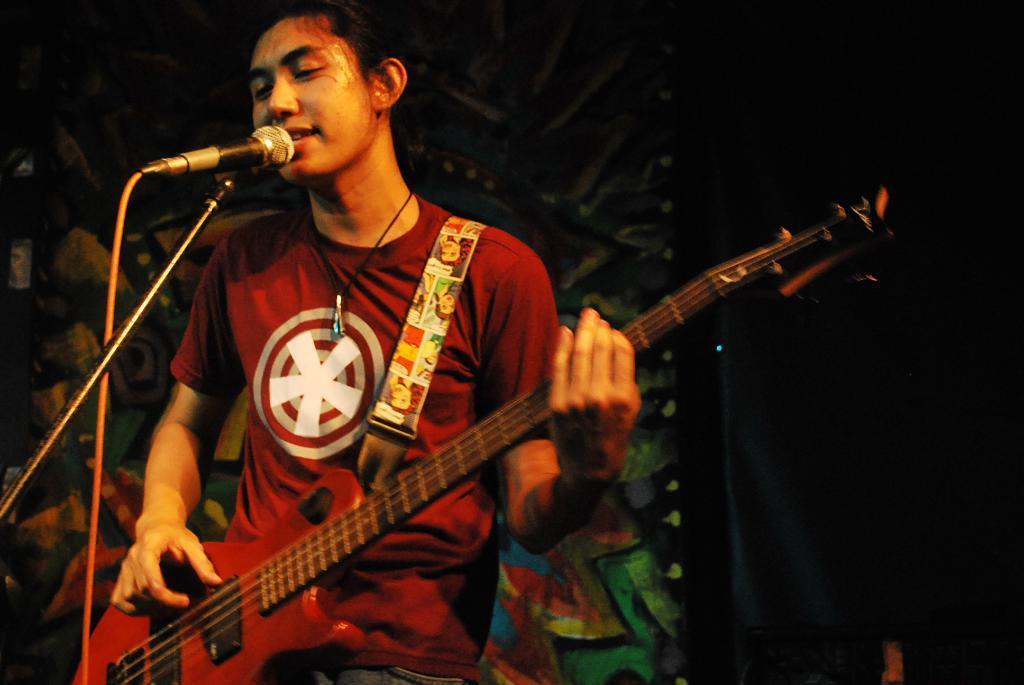Could you give a brief overview of what you see in this image? This is a picture of a man in red t shirt holding a guitar and singing a song in front of the man there is a microphone with stand. Behind the man there is a wall with paintings. 